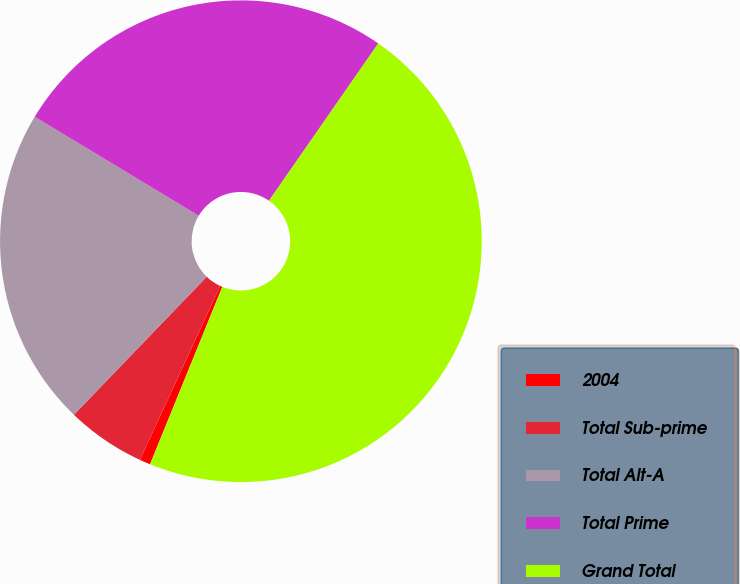Convert chart to OTSL. <chart><loc_0><loc_0><loc_500><loc_500><pie_chart><fcel>2004<fcel>Total Sub-prime<fcel>Total Alt-A<fcel>Total Prime<fcel>Grand Total<nl><fcel>0.73%<fcel>5.31%<fcel>21.45%<fcel>26.02%<fcel>46.49%<nl></chart> 